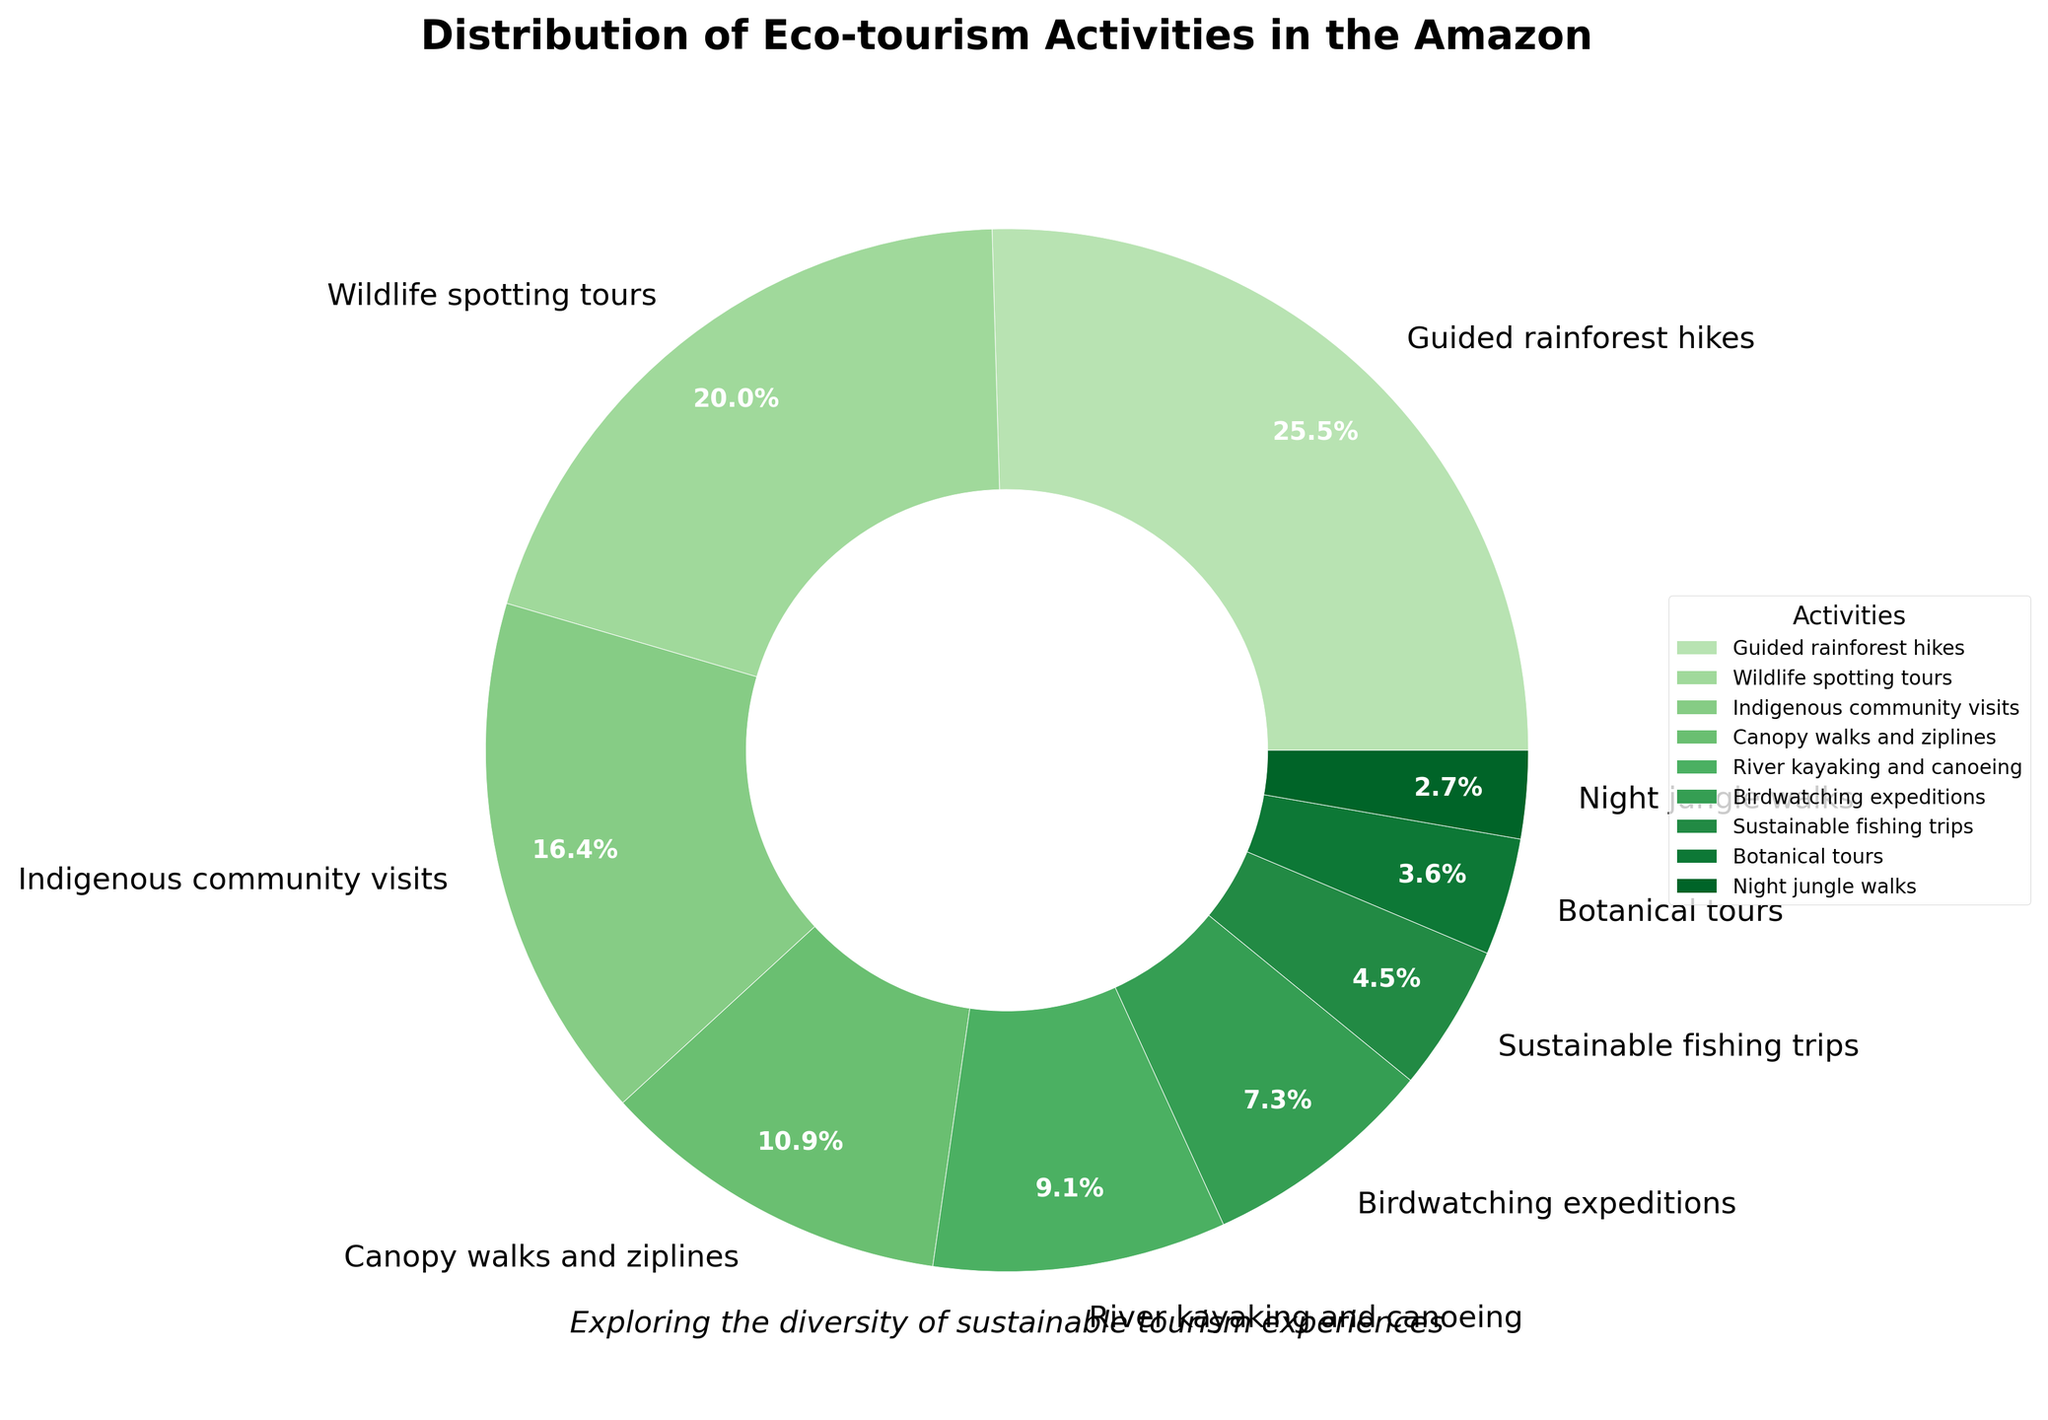What eco-tourism activity takes up the largest percentage? The figure shows a pie chart where each slice represents a different eco-tourism activity and its corresponding percentage. The largest slice represents "Guided rainforest hikes" with 28%.
Answer: Guided rainforest hikes Which activities together make up more than half of the total eco-tourism activities offered? To determine this, add the percentages of the largest slices until the sum exceeds 50%. "Guided rainforest hikes" (28%) and "Wildlife spotting tours" (22%) together total 50%. Adding "Indigenous community visits" (18%) brings the total to 68%, which is more than half.
Answer: Guided rainforest hikes, Wildlife spotting tours, and Indigenous community visits How much larger is the percentage of canopy walks and ziplines compared to night jungle walks? Find the percentage of "Canopy walks and ziplines" (12%) and "Night jungle walks" (3%) and subtract the smaller from the larger: 12% - 3% = 9%.
Answer: 9% Which activities have a percentage less than 10%? Any slice representing less than 10% would fall under this category. These activities are "River kayaking and canoeing" (10%), "Birdwatching expeditions" (8%), "Sustainable fishing trips" (5%), "Botanical tours" (4%), and "Night jungle walks" (3%).
Answer: River kayaking and canoeing, Birdwatching expeditions, Sustainable fishing trips, Botanical tours, Night jungle walks What is the combined percentage of the least three popular activities? Identify the slices with the smallest percentages and sum them up. The least popular activities are "Night jungle walks" (3%), "Botanical tours" (4%), and "Sustainable fishing trips" (5%). Their combined percentage is 3% + 4% + 5% = 12%.
Answer: 12% Which activities together account for around one-fourth of the total offered activities? Look for activities where the sum of their percentages is close to 25%. "Wildlife spotting tours" account for 22%, so adding "Night jungle walks" (3%) makes it 25%.
Answer: Wildlife spotting tours and Night jungle walks By what percentage does the percentage of wildlife spotting tours exceed birdwatching expeditions? Find the percentage difference between "Wildlife spotting tours" (22%) and "Birdwatching expeditions" (8%): 22% - 8% = 14%.
Answer: 14% Which activity has the smallest percentage? Identify the smallest slice in the pie chart, which is "Night jungle walks" at 3%.
Answer: Night jungle walks Which activities make up more or equal to the percentage of river kayaking and canoeing combined? "River kayaking and canoeing" is 10%. Summing activities that have a combined percentage of at least 10%, we have "River kayaking and canoeing" (10%) alone and any single activity with a percentage of 10% or more: "Guided rainforest hikes" (28%), "Wildlife spotting tours" (22%), "Indigenous community visits" (18%), "Canopy walks and ziplines" (12%).
Answer: Guided rainforest hikes, Wildlife spotting tours, Indigenous community visits, Canopy walks and ziplines, River kayaking and canoeing 